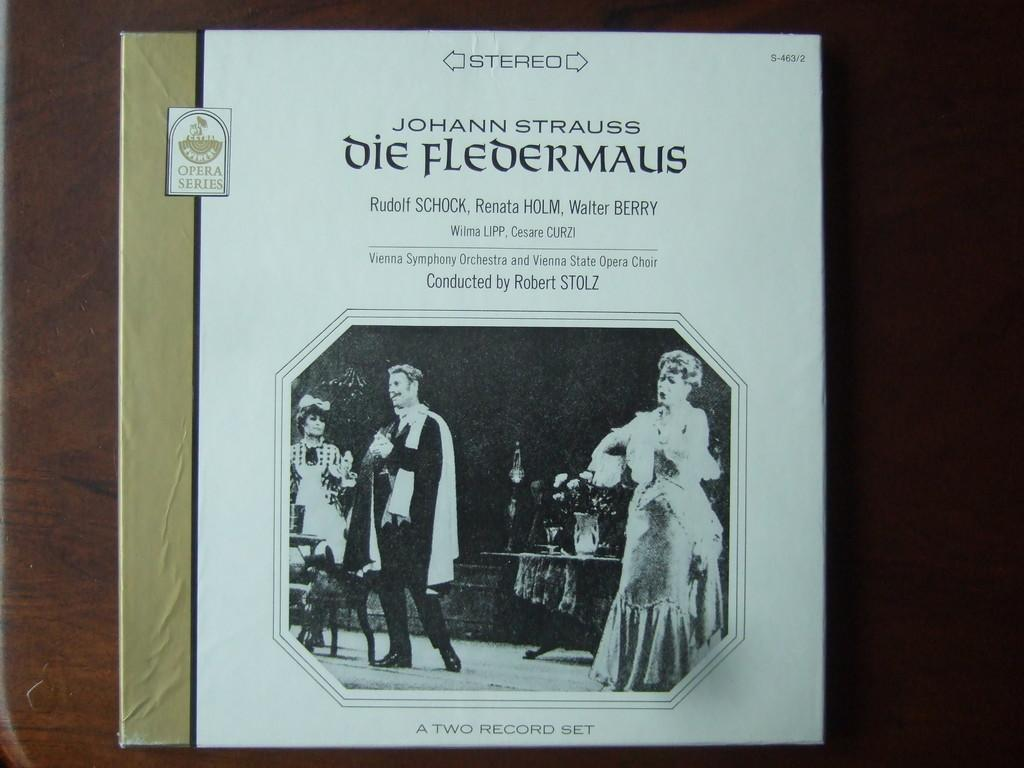<image>
Share a concise interpretation of the image provided. Johann Strauss Die Fledermalis book from the Opera series. 